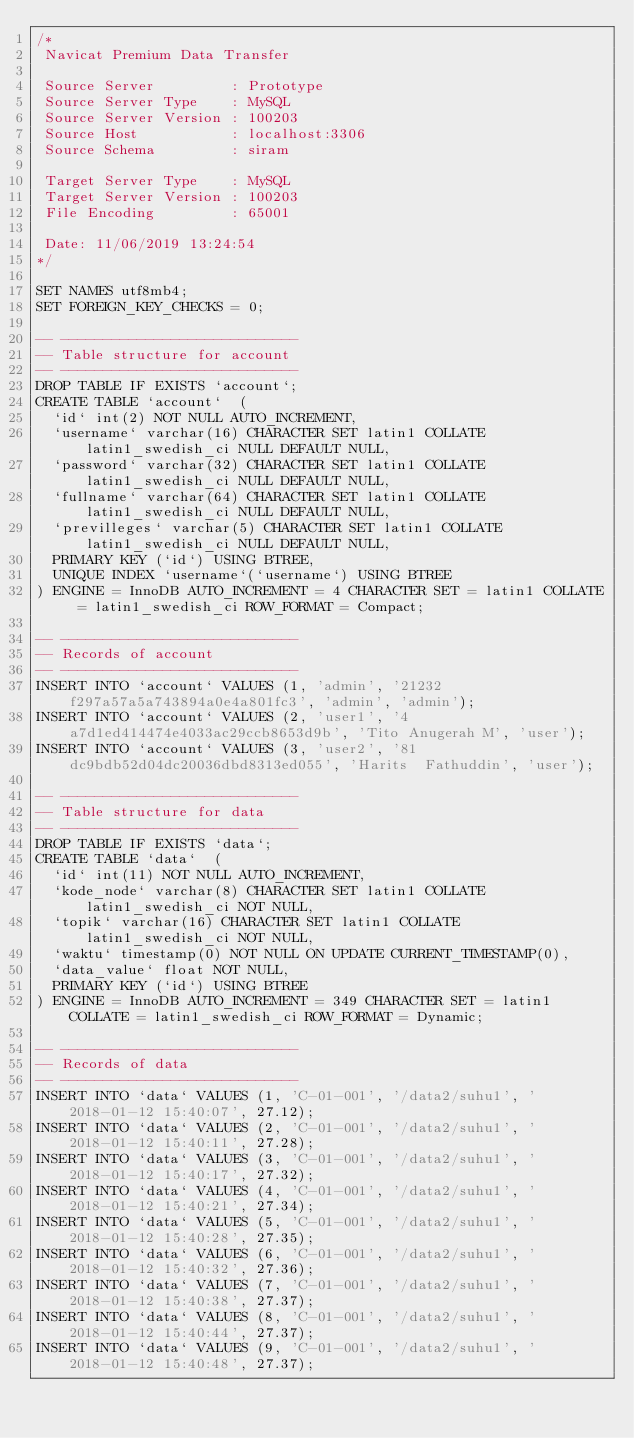<code> <loc_0><loc_0><loc_500><loc_500><_SQL_>/*
 Navicat Premium Data Transfer

 Source Server         : Prototype
 Source Server Type    : MySQL
 Source Server Version : 100203
 Source Host           : localhost:3306
 Source Schema         : siram

 Target Server Type    : MySQL
 Target Server Version : 100203
 File Encoding         : 65001

 Date: 11/06/2019 13:24:54
*/

SET NAMES utf8mb4;
SET FOREIGN_KEY_CHECKS = 0;

-- ----------------------------
-- Table structure for account
-- ----------------------------
DROP TABLE IF EXISTS `account`;
CREATE TABLE `account`  (
  `id` int(2) NOT NULL AUTO_INCREMENT,
  `username` varchar(16) CHARACTER SET latin1 COLLATE latin1_swedish_ci NULL DEFAULT NULL,
  `password` varchar(32) CHARACTER SET latin1 COLLATE latin1_swedish_ci NULL DEFAULT NULL,
  `fullname` varchar(64) CHARACTER SET latin1 COLLATE latin1_swedish_ci NULL DEFAULT NULL,
  `previlleges` varchar(5) CHARACTER SET latin1 COLLATE latin1_swedish_ci NULL DEFAULT NULL,
  PRIMARY KEY (`id`) USING BTREE,
  UNIQUE INDEX `username`(`username`) USING BTREE
) ENGINE = InnoDB AUTO_INCREMENT = 4 CHARACTER SET = latin1 COLLATE = latin1_swedish_ci ROW_FORMAT = Compact;

-- ----------------------------
-- Records of account
-- ----------------------------
INSERT INTO `account` VALUES (1, 'admin', '21232f297a57a5a743894a0e4a801fc3', 'admin', 'admin');
INSERT INTO `account` VALUES (2, 'user1', '4a7d1ed414474e4033ac29ccb8653d9b', 'Tito Anugerah M', 'user');
INSERT INTO `account` VALUES (3, 'user2', '81dc9bdb52d04dc20036dbd8313ed055', 'Harits  Fathuddin', 'user');

-- ----------------------------
-- Table structure for data
-- ----------------------------
DROP TABLE IF EXISTS `data`;
CREATE TABLE `data`  (
  `id` int(11) NOT NULL AUTO_INCREMENT,
  `kode_node` varchar(8) CHARACTER SET latin1 COLLATE latin1_swedish_ci NOT NULL,
  `topik` varchar(16) CHARACTER SET latin1 COLLATE latin1_swedish_ci NOT NULL,
  `waktu` timestamp(0) NOT NULL ON UPDATE CURRENT_TIMESTAMP(0),
  `data_value` float NOT NULL,
  PRIMARY KEY (`id`) USING BTREE
) ENGINE = InnoDB AUTO_INCREMENT = 349 CHARACTER SET = latin1 COLLATE = latin1_swedish_ci ROW_FORMAT = Dynamic;

-- ----------------------------
-- Records of data
-- ----------------------------
INSERT INTO `data` VALUES (1, 'C-01-001', '/data2/suhu1', '2018-01-12 15:40:07', 27.12);
INSERT INTO `data` VALUES (2, 'C-01-001', '/data2/suhu1', '2018-01-12 15:40:11', 27.28);
INSERT INTO `data` VALUES (3, 'C-01-001', '/data2/suhu1', '2018-01-12 15:40:17', 27.32);
INSERT INTO `data` VALUES (4, 'C-01-001', '/data2/suhu1', '2018-01-12 15:40:21', 27.34);
INSERT INTO `data` VALUES (5, 'C-01-001', '/data2/suhu1', '2018-01-12 15:40:28', 27.35);
INSERT INTO `data` VALUES (6, 'C-01-001', '/data2/suhu1', '2018-01-12 15:40:32', 27.36);
INSERT INTO `data` VALUES (7, 'C-01-001', '/data2/suhu1', '2018-01-12 15:40:38', 27.37);
INSERT INTO `data` VALUES (8, 'C-01-001', '/data2/suhu1', '2018-01-12 15:40:44', 27.37);
INSERT INTO `data` VALUES (9, 'C-01-001', '/data2/suhu1', '2018-01-12 15:40:48', 27.37);</code> 